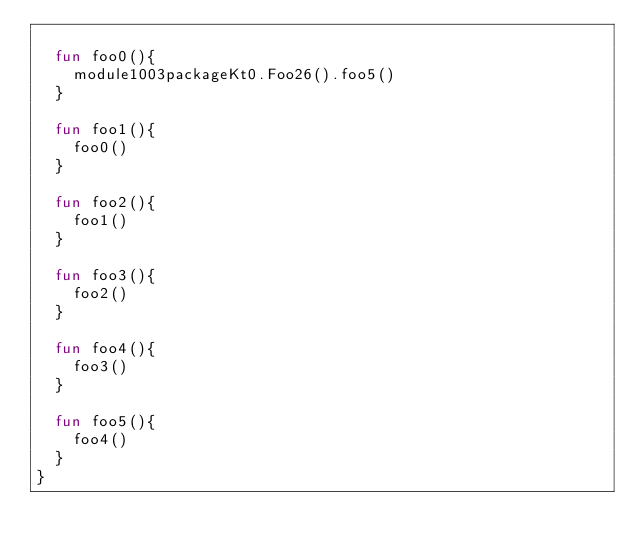Convert code to text. <code><loc_0><loc_0><loc_500><loc_500><_Kotlin_>
  fun foo0(){
    module1003packageKt0.Foo26().foo5()
  }

  fun foo1(){
    foo0()
  }

  fun foo2(){
    foo1()
  }

  fun foo3(){
    foo2()
  }

  fun foo4(){
    foo3()
  }

  fun foo5(){
    foo4()
  }
}</code> 